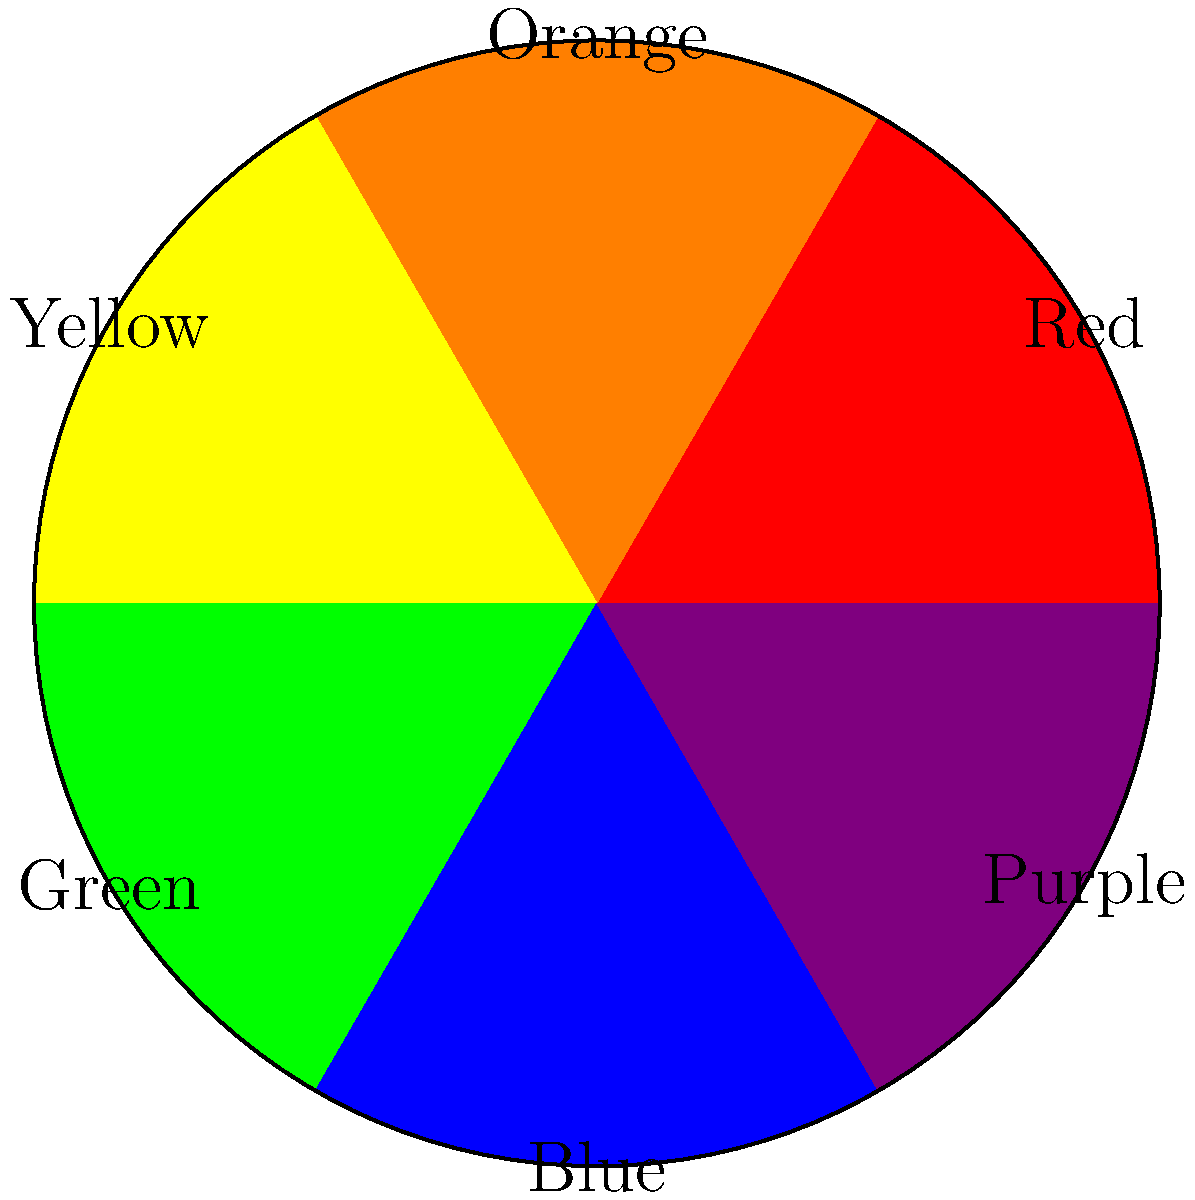As someone who supported your sibling's artistic journey, you're familiar with the color wheel used in their work. Which color is complementary to yellow on this artist's color wheel? To determine the complementary color of yellow on this color wheel, we need to follow these steps:

1. Locate yellow on the color wheel: Yellow is positioned between orange and green.

2. Identify the complementary color: Complementary colors are directly opposite each other on the color wheel.

3. Find the color opposite to yellow: Starting from yellow, we move 180 degrees around the wheel.

4. Observe the result: The color directly opposite yellow is purple.

Understanding complementary colors is crucial in art, as they create strong contrast and visual interest when used together. This knowledge would have been valuable in appreciating and supporting your sibling's artistic work during their first solo exhibition.
Answer: Purple 